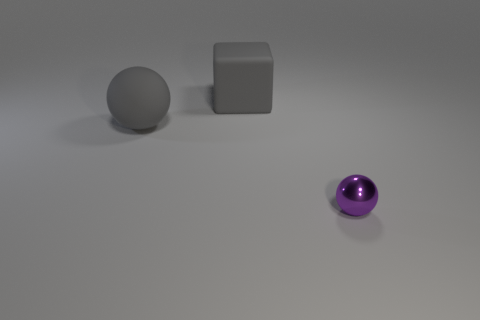The tiny sphere has what color?
Offer a terse response. Purple. Is there a large metallic cylinder that has the same color as the metallic sphere?
Your response must be concise. No. Does the ball behind the purple metallic object have the same color as the tiny object?
Ensure brevity in your answer.  No. What number of things are spheres that are behind the tiny purple metal thing or red rubber cylinders?
Your response must be concise. 1. Are there any purple shiny balls to the left of the small object?
Your response must be concise. No. What is the material of the big block that is the same color as the rubber sphere?
Ensure brevity in your answer.  Rubber. Is the material of the sphere that is behind the purple thing the same as the tiny ball?
Offer a terse response. No. There is a big gray matte thing that is in front of the gray rubber object that is behind the large ball; is there a purple thing left of it?
Keep it short and to the point. No. What number of spheres are matte things or purple shiny objects?
Offer a very short reply. 2. There is a sphere on the left side of the large matte block; what is its material?
Your response must be concise. Rubber. 